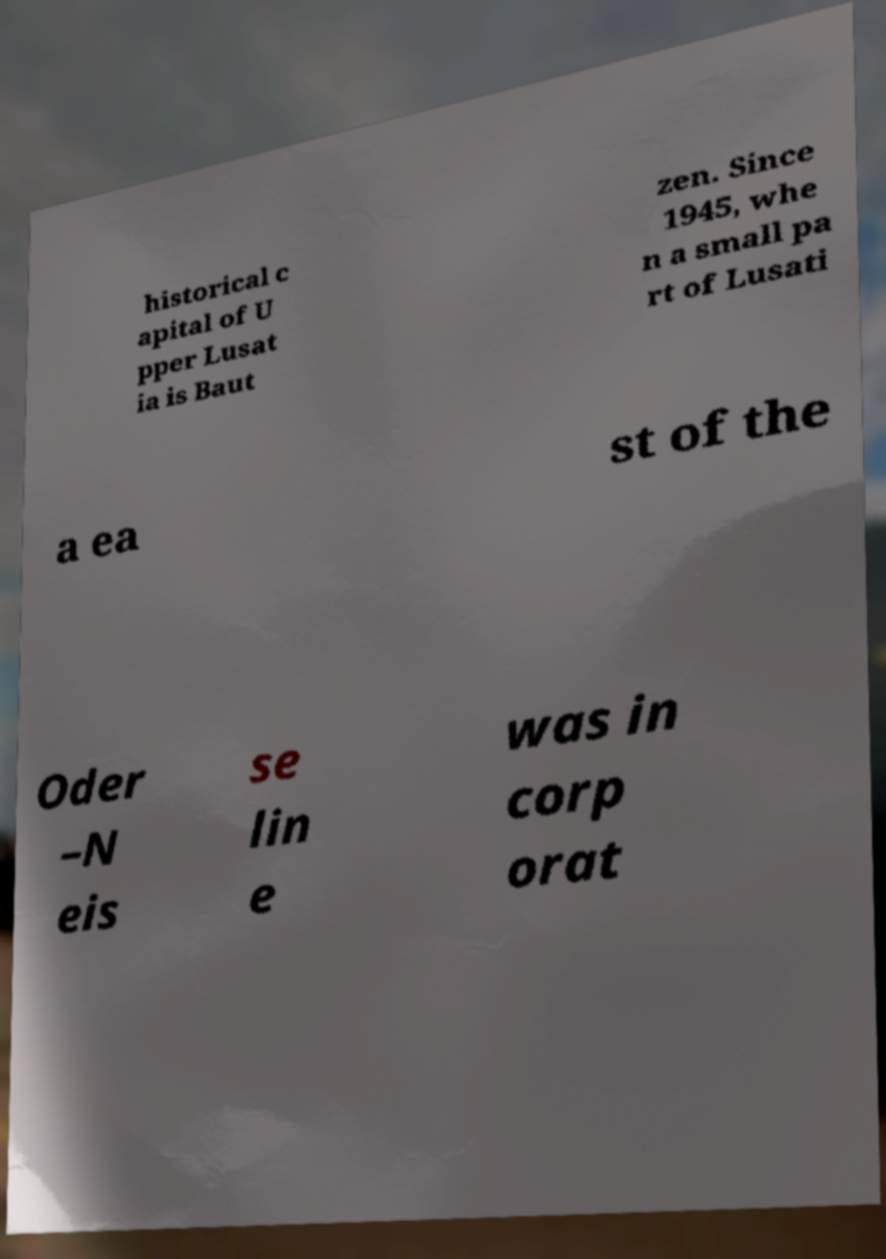For documentation purposes, I need the text within this image transcribed. Could you provide that? historical c apital of U pper Lusat ia is Baut zen. Since 1945, whe n a small pa rt of Lusati a ea st of the Oder –N eis se lin e was in corp orat 